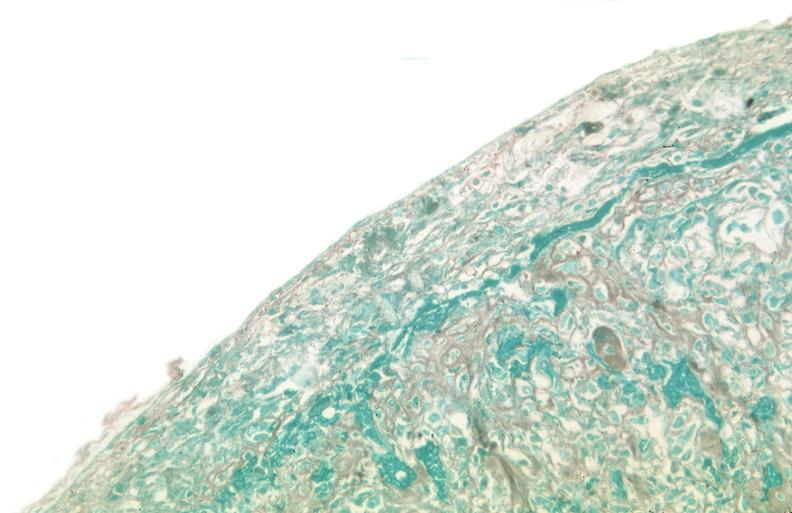how many antitrypsin was talc used to sclerose emphysematous lung, alpha-deficiency?
Answer the question using a single word or phrase. 1 